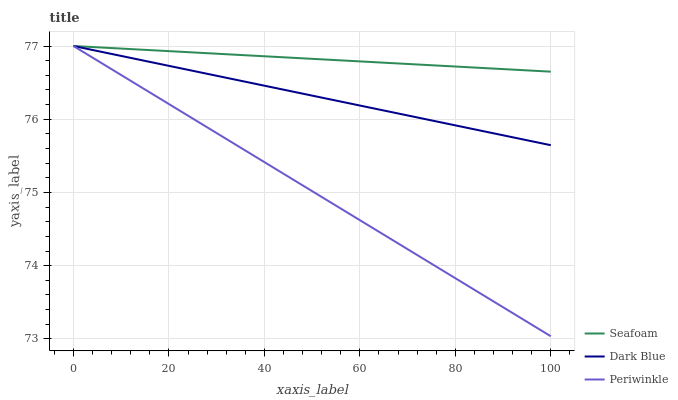Does Seafoam have the minimum area under the curve?
Answer yes or no. No. Does Periwinkle have the maximum area under the curve?
Answer yes or no. No. Is Seafoam the smoothest?
Answer yes or no. No. Is Seafoam the roughest?
Answer yes or no. No. Does Seafoam have the lowest value?
Answer yes or no. No. 